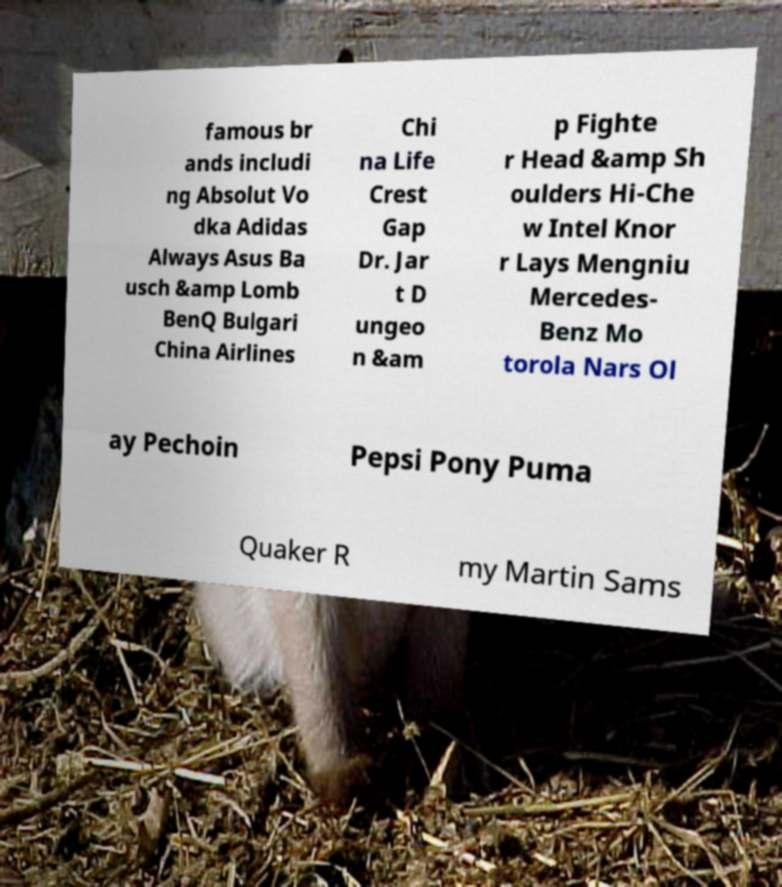Can you read and provide the text displayed in the image?This photo seems to have some interesting text. Can you extract and type it out for me? famous br ands includi ng Absolut Vo dka Adidas Always Asus Ba usch &amp Lomb BenQ Bulgari China Airlines Chi na Life Crest Gap Dr. Jar t D ungeo n &am p Fighte r Head &amp Sh oulders Hi-Che w Intel Knor r Lays Mengniu Mercedes- Benz Mo torola Nars Ol ay Pechoin Pepsi Pony Puma Quaker R my Martin Sams 